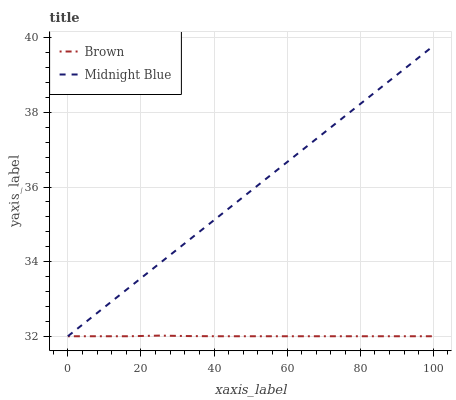Does Brown have the minimum area under the curve?
Answer yes or no. Yes. Does Midnight Blue have the maximum area under the curve?
Answer yes or no. Yes. Does Midnight Blue have the minimum area under the curve?
Answer yes or no. No. Is Midnight Blue the smoothest?
Answer yes or no. Yes. Is Brown the roughest?
Answer yes or no. Yes. Is Midnight Blue the roughest?
Answer yes or no. No. Does Brown have the lowest value?
Answer yes or no. Yes. Does Midnight Blue have the highest value?
Answer yes or no. Yes. Does Midnight Blue intersect Brown?
Answer yes or no. Yes. Is Midnight Blue less than Brown?
Answer yes or no. No. Is Midnight Blue greater than Brown?
Answer yes or no. No. 